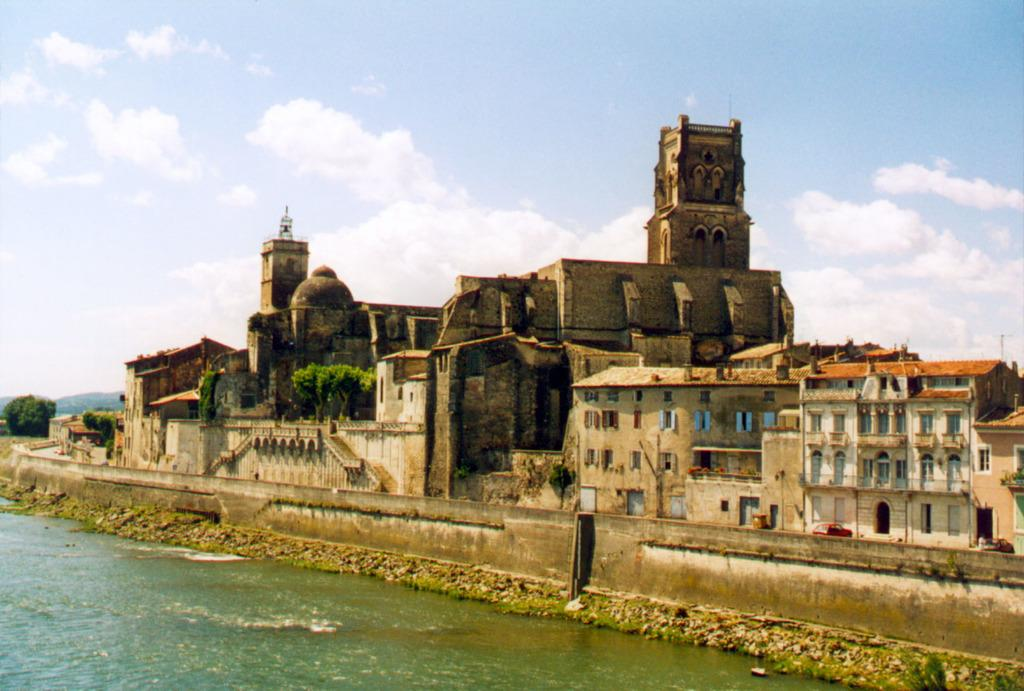What type of natural feature can be seen in the image? There is a lake in the image. What type of structure is visible in the image? There is a fort in the image. What type of man-made structures can be seen in the image? There are buildings in the image. What type of transportation is parked in the image? Vehicles are parked on the road in the image. What type of vegetation is present in the image? Trees are present in the image. What is the condition of the sky in the image? The sky is clear in the image. What type of disease is spreading among the trees in the image? There is no indication of any disease among the trees in the image; they appear healthy. Can you identify the crook who is hiding behind the fort in the image? There is no crook or any person hiding behind the fort in the image. 